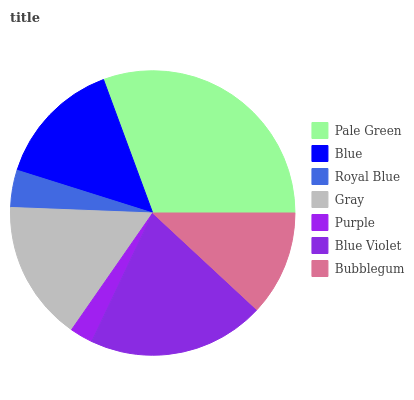Is Purple the minimum?
Answer yes or no. Yes. Is Pale Green the maximum?
Answer yes or no. Yes. Is Blue the minimum?
Answer yes or no. No. Is Blue the maximum?
Answer yes or no. No. Is Pale Green greater than Blue?
Answer yes or no. Yes. Is Blue less than Pale Green?
Answer yes or no. Yes. Is Blue greater than Pale Green?
Answer yes or no. No. Is Pale Green less than Blue?
Answer yes or no. No. Is Blue the high median?
Answer yes or no. Yes. Is Blue the low median?
Answer yes or no. Yes. Is Gray the high median?
Answer yes or no. No. Is Bubblegum the low median?
Answer yes or no. No. 